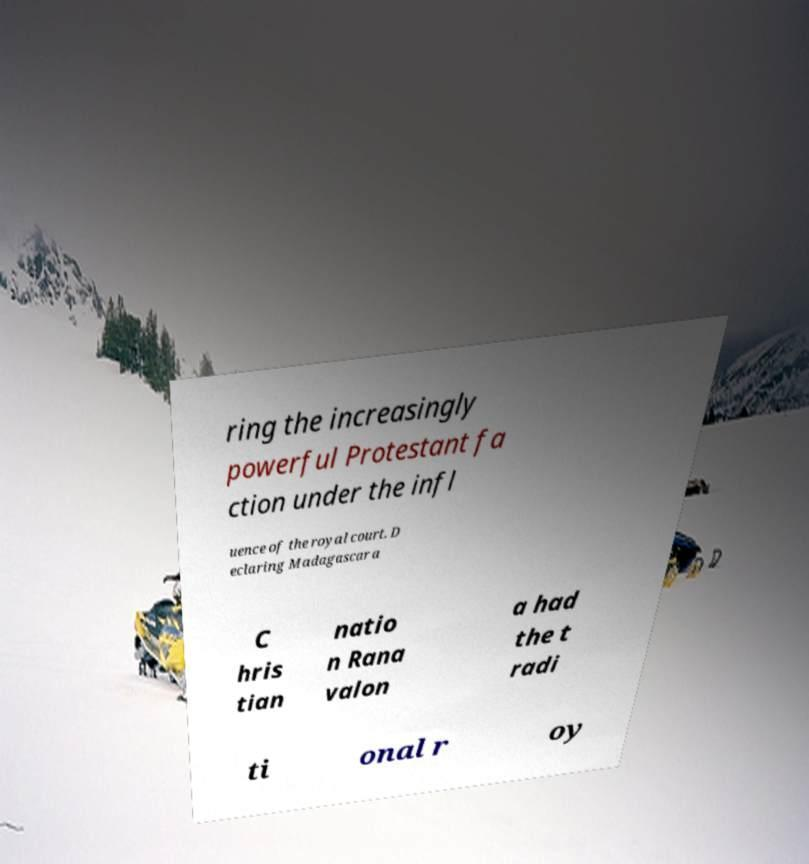I need the written content from this picture converted into text. Can you do that? ring the increasingly powerful Protestant fa ction under the infl uence of the royal court. D eclaring Madagascar a C hris tian natio n Rana valon a had the t radi ti onal r oy 